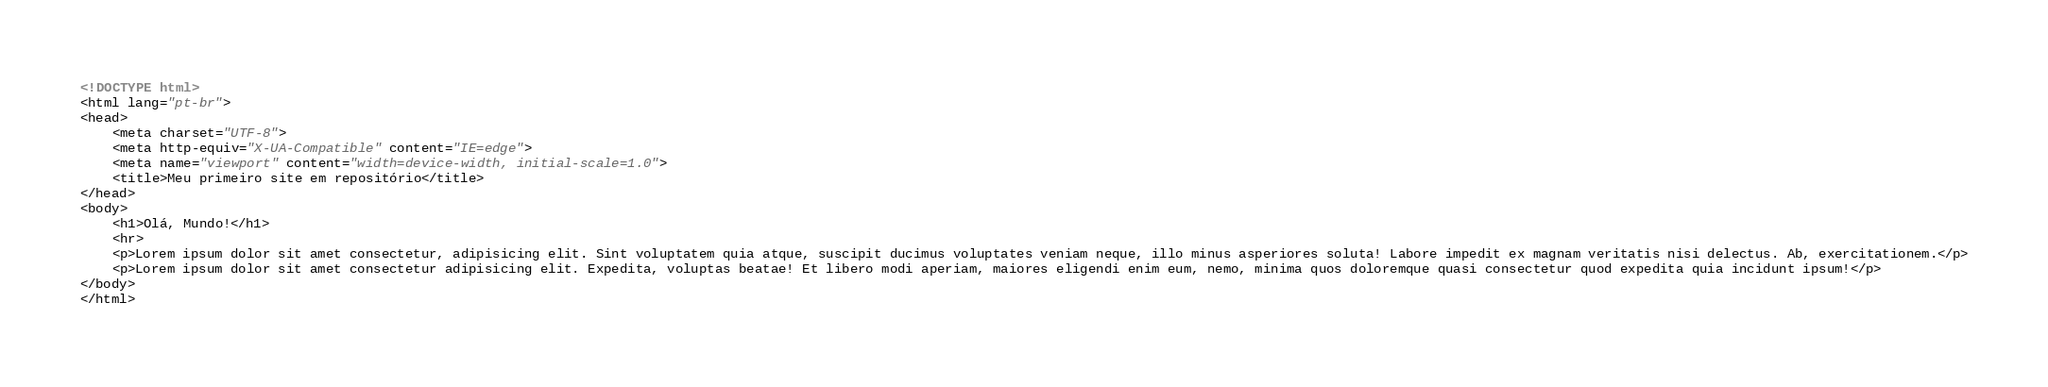<code> <loc_0><loc_0><loc_500><loc_500><_HTML_><!DOCTYPE html>
<html lang="pt-br">
<head>
    <meta charset="UTF-8">
    <meta http-equiv="X-UA-Compatible" content="IE=edge">
    <meta name="viewport" content="width=device-width, initial-scale=1.0">
    <title>Meu primeiro site em repositório</title>
</head>
<body>
    <h1>Olá, Mundo!</h1>
    <hr>
    <p>Lorem ipsum dolor sit amet consectetur, adipisicing elit. Sint voluptatem quia atque, suscipit ducimus voluptates veniam neque, illo minus asperiores soluta! Labore impedit ex magnam veritatis nisi delectus. Ab, exercitationem.</p>
    <p>Lorem ipsum dolor sit amet consectetur adipisicing elit. Expedita, voluptas beatae! Et libero modi aperiam, maiores eligendi enim eum, nemo, minima quos doloremque quasi consectetur quod expedita quia incidunt ipsum!</p>
</body>
</html></code> 